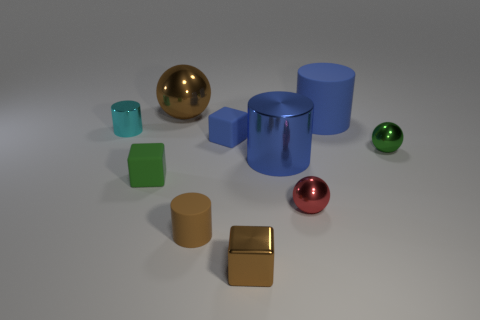What is the size of the ball that is both in front of the small blue block and behind the tiny green rubber block?
Make the answer very short. Small. Is the number of red metal spheres that are in front of the tiny red object greater than the number of tiny blue rubber objects?
Provide a succinct answer. No. How many balls are either brown objects or large objects?
Keep it short and to the point. 1. What is the shape of the tiny object that is in front of the cyan cylinder and to the left of the brown ball?
Offer a very short reply. Cube. Is the number of big blue metal cylinders that are behind the green metallic object the same as the number of green matte objects behind the brown shiny sphere?
Your response must be concise. Yes. How many objects are either cyan matte balls or tiny brown matte cylinders?
Offer a terse response. 1. There is a rubber cylinder that is the same size as the red shiny object; what color is it?
Provide a short and direct response. Brown. How many objects are either small brown objects behind the tiny metallic cube or small metallic objects behind the tiny red thing?
Your answer should be very brief. 3. Are there an equal number of small brown rubber cylinders in front of the brown block and big metallic spheres?
Provide a succinct answer. No. There is a blue cylinder that is behind the green shiny sphere; does it have the same size as the shiny thing behind the cyan thing?
Your answer should be very brief. Yes. 